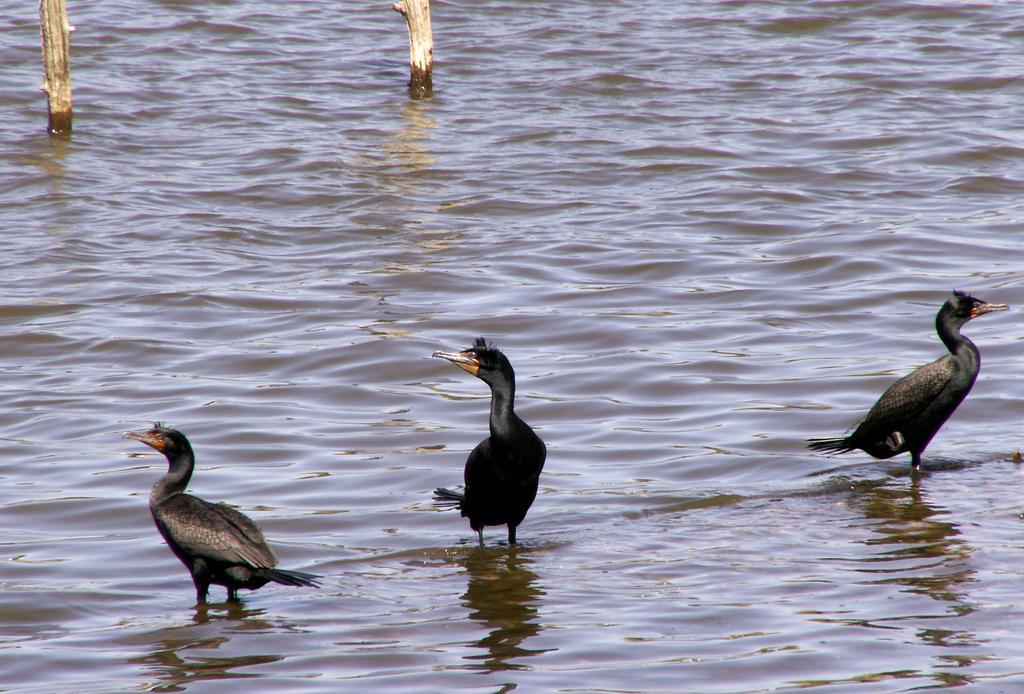Could you give a brief overview of what you see in this image? We can see birds and water and we can see wooden poles. 